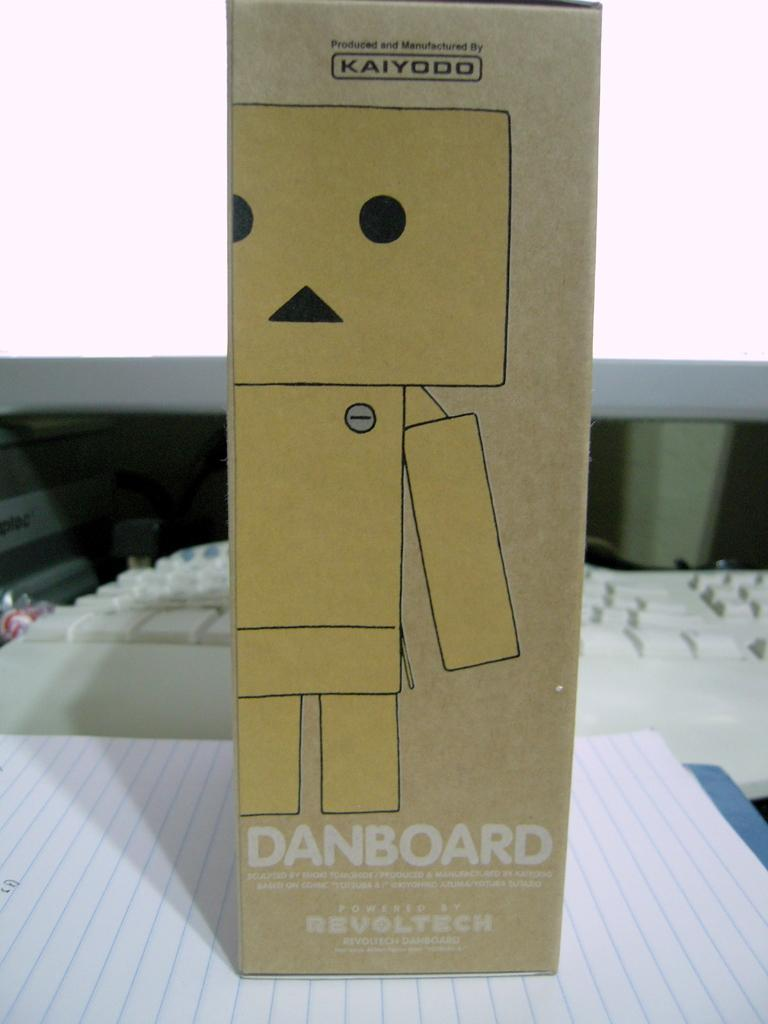<image>
Summarize the visual content of the image. A danboard box sits next to a keyboard 